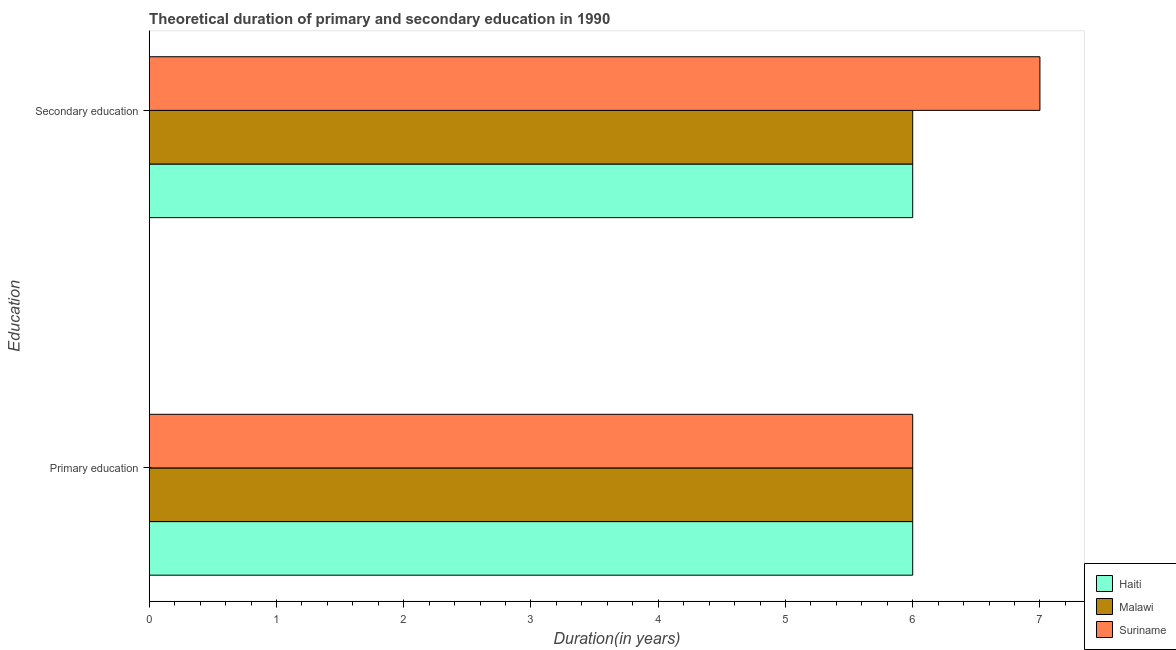Are the number of bars per tick equal to the number of legend labels?
Keep it short and to the point. Yes. How many bars are there on the 1st tick from the top?
Offer a terse response. 3. How many bars are there on the 2nd tick from the bottom?
Provide a short and direct response. 3. What is the label of the 1st group of bars from the top?
Keep it short and to the point. Secondary education. What is the duration of primary education in Malawi?
Offer a very short reply. 6. Across all countries, what is the maximum duration of secondary education?
Provide a short and direct response. 7. Across all countries, what is the minimum duration of secondary education?
Ensure brevity in your answer.  6. In which country was the duration of secondary education maximum?
Offer a terse response. Suriname. In which country was the duration of primary education minimum?
Your answer should be very brief. Haiti. What is the total duration of primary education in the graph?
Make the answer very short. 18. What is the difference between the duration of primary education in Haiti and that in Suriname?
Your response must be concise. 0. What is the difference between the duration of primary education in Haiti and the duration of secondary education in Malawi?
Your answer should be compact. 0. What is the average duration of secondary education per country?
Make the answer very short. 6.33. What is the difference between the duration of primary education and duration of secondary education in Suriname?
Your response must be concise. -1. What is the ratio of the duration of primary education in Malawi to that in Suriname?
Keep it short and to the point. 1. Is the duration of secondary education in Suriname less than that in Haiti?
Make the answer very short. No. What does the 2nd bar from the top in Secondary education represents?
Make the answer very short. Malawi. What does the 3rd bar from the bottom in Primary education represents?
Provide a succinct answer. Suriname. How many bars are there?
Give a very brief answer. 6. What is the difference between two consecutive major ticks on the X-axis?
Ensure brevity in your answer.  1. Does the graph contain any zero values?
Your answer should be compact. No. Does the graph contain grids?
Your answer should be very brief. No. Where does the legend appear in the graph?
Offer a terse response. Bottom right. How many legend labels are there?
Offer a very short reply. 3. What is the title of the graph?
Offer a very short reply. Theoretical duration of primary and secondary education in 1990. Does "Libya" appear as one of the legend labels in the graph?
Your response must be concise. No. What is the label or title of the X-axis?
Offer a very short reply. Duration(in years). What is the label or title of the Y-axis?
Provide a short and direct response. Education. What is the Duration(in years) of Haiti in Primary education?
Give a very brief answer. 6. What is the Duration(in years) of Malawi in Primary education?
Offer a terse response. 6. What is the Duration(in years) of Haiti in Secondary education?
Offer a terse response. 6. What is the Duration(in years) of Suriname in Secondary education?
Your answer should be compact. 7. Across all Education, what is the maximum Duration(in years) of Malawi?
Make the answer very short. 6. Across all Education, what is the minimum Duration(in years) of Haiti?
Your response must be concise. 6. Across all Education, what is the minimum Duration(in years) of Malawi?
Ensure brevity in your answer.  6. Across all Education, what is the minimum Duration(in years) of Suriname?
Keep it short and to the point. 6. What is the total Duration(in years) of Haiti in the graph?
Offer a very short reply. 12. What is the total Duration(in years) in Malawi in the graph?
Give a very brief answer. 12. What is the total Duration(in years) in Suriname in the graph?
Provide a succinct answer. 13. What is the difference between the Duration(in years) in Haiti in Primary education and the Duration(in years) in Malawi in Secondary education?
Provide a short and direct response. 0. What is the average Duration(in years) in Malawi per Education?
Provide a succinct answer. 6. What is the difference between the Duration(in years) in Haiti and Duration(in years) in Suriname in Secondary education?
Offer a very short reply. -1. What is the ratio of the Duration(in years) in Haiti in Primary education to that in Secondary education?
Make the answer very short. 1. What is the ratio of the Duration(in years) in Suriname in Primary education to that in Secondary education?
Offer a terse response. 0.86. What is the difference between the highest and the second highest Duration(in years) in Malawi?
Your answer should be compact. 0. What is the difference between the highest and the lowest Duration(in years) of Malawi?
Your answer should be very brief. 0. What is the difference between the highest and the lowest Duration(in years) of Suriname?
Keep it short and to the point. 1. 